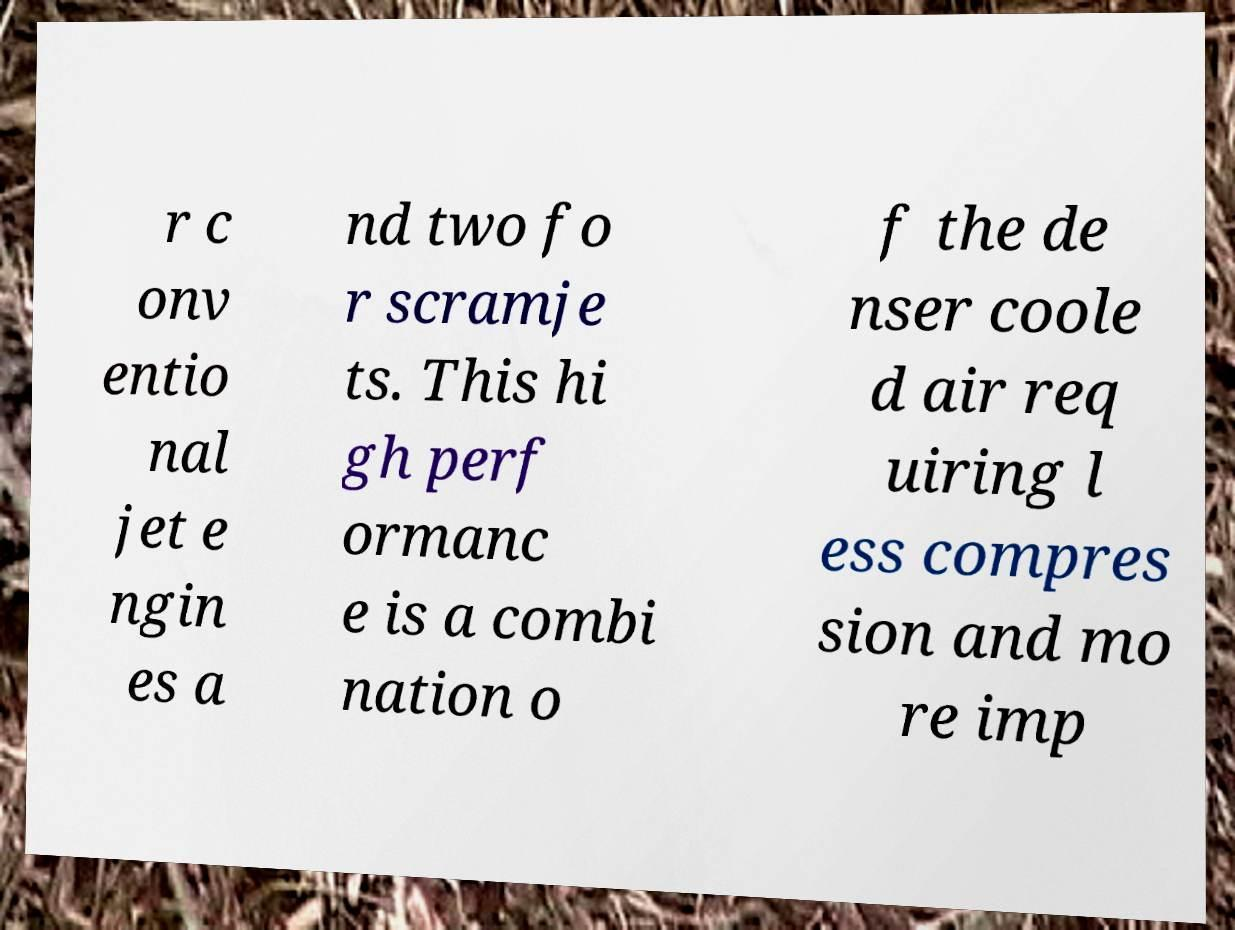What messages or text are displayed in this image? I need them in a readable, typed format. r c onv entio nal jet e ngin es a nd two fo r scramje ts. This hi gh perf ormanc e is a combi nation o f the de nser coole d air req uiring l ess compres sion and mo re imp 